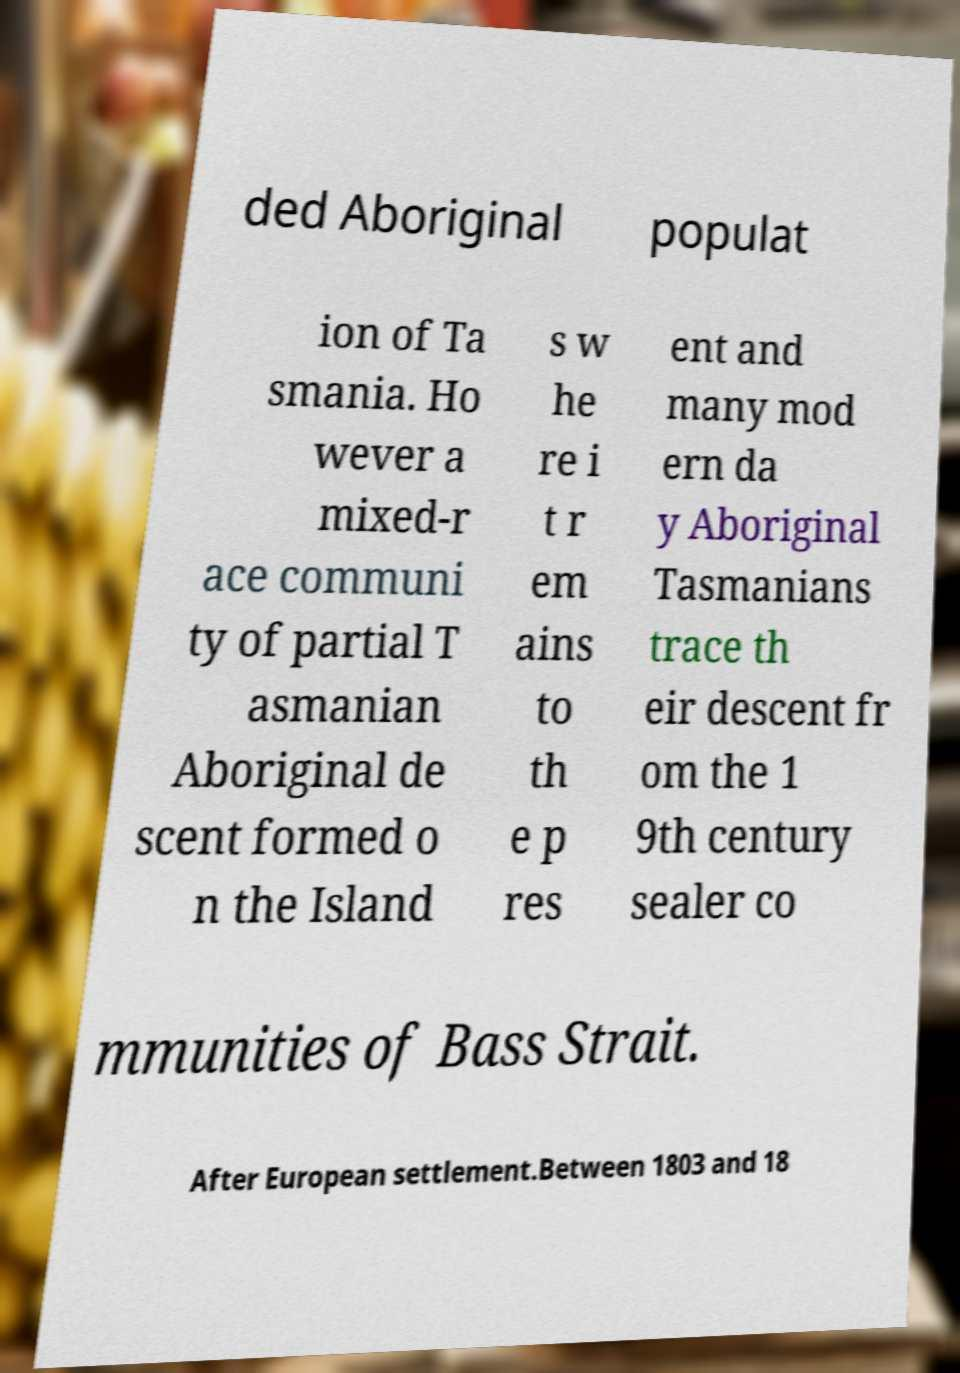What messages or text are displayed in this image? I need them in a readable, typed format. ded Aboriginal populat ion of Ta smania. Ho wever a mixed-r ace communi ty of partial T asmanian Aboriginal de scent formed o n the Island s w he re i t r em ains to th e p res ent and many mod ern da y Aboriginal Tasmanians trace th eir descent fr om the 1 9th century sealer co mmunities of Bass Strait. After European settlement.Between 1803 and 18 